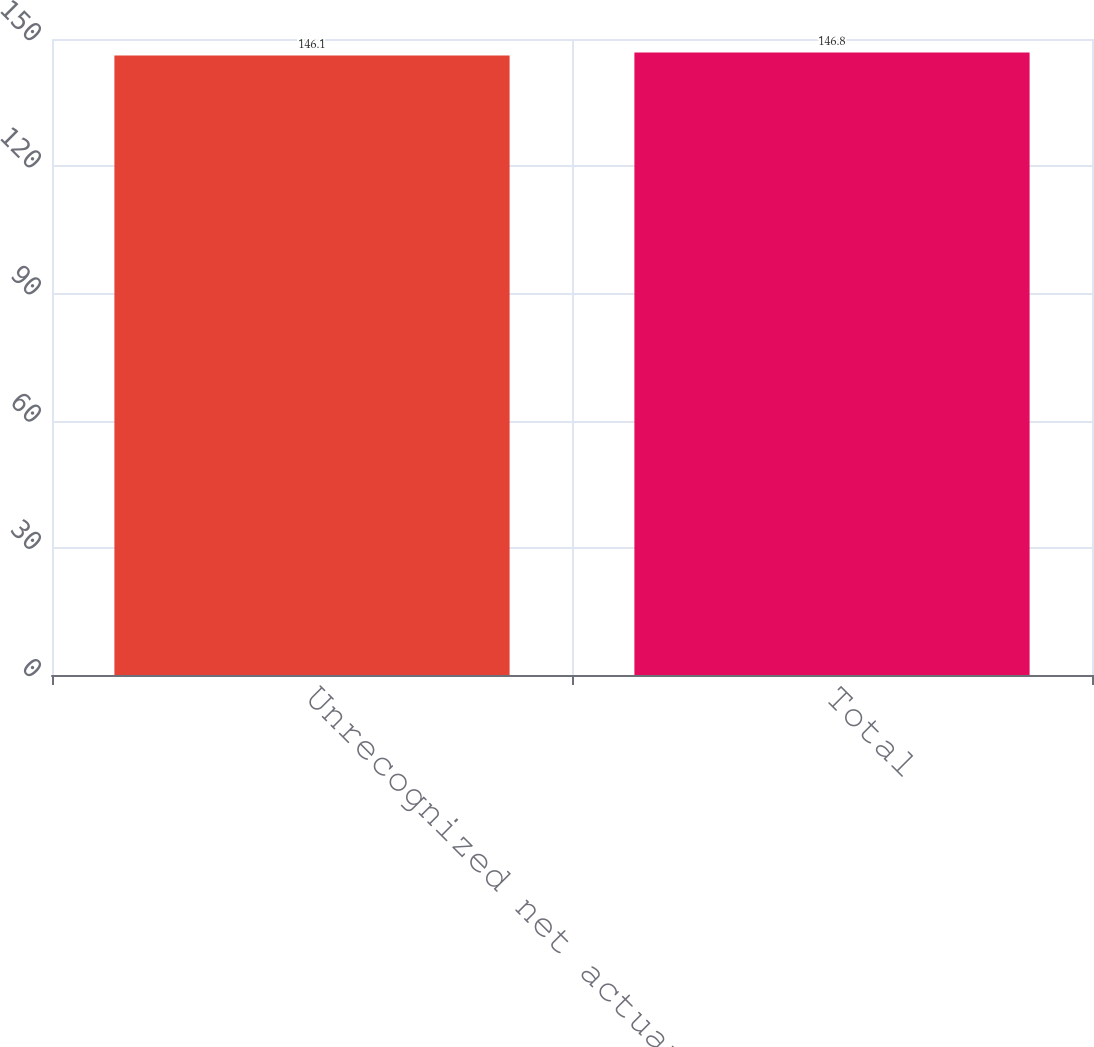<chart> <loc_0><loc_0><loc_500><loc_500><bar_chart><fcel>Unrecognized net actuarial<fcel>Total<nl><fcel>146.1<fcel>146.8<nl></chart> 